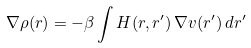<formula> <loc_0><loc_0><loc_500><loc_500>\nabla \rho ( r ) = - \beta \int H ( r , r ^ { \prime } ) \, \nabla v ( r ^ { \prime } ) \, d r ^ { \prime }</formula> 